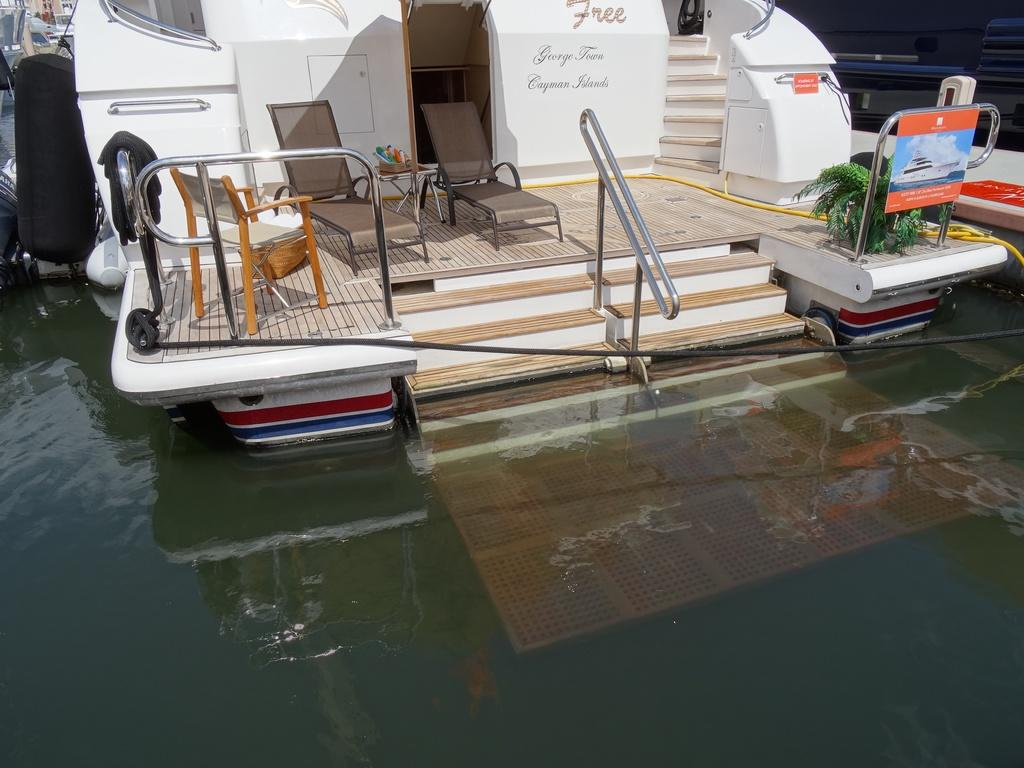What is the main subject of the image? The main subject of the image is a boat. Where is the boat located? The boat is on the water. What furniture is present in the boat? There are chairs and a table in the boat. What is on the table in the boat? There are objects on the table. Is there any greenery in the boat? Yes, there is a plant in a pot in the boat. What nation is represented by the flag on the boat in the image? There is no flag visible on the boat in the image. How many matches are being played on the table in the image? There are no matches present in the image; it only shows a boat with chairs, a table, objects, and a plant in a pot. 